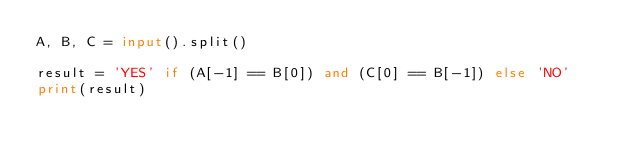<code> <loc_0><loc_0><loc_500><loc_500><_Python_>A, B, C = input().split()

result = 'YES' if (A[-1] == B[0]) and (C[0] == B[-1]) else 'NO'
print(result)
</code> 